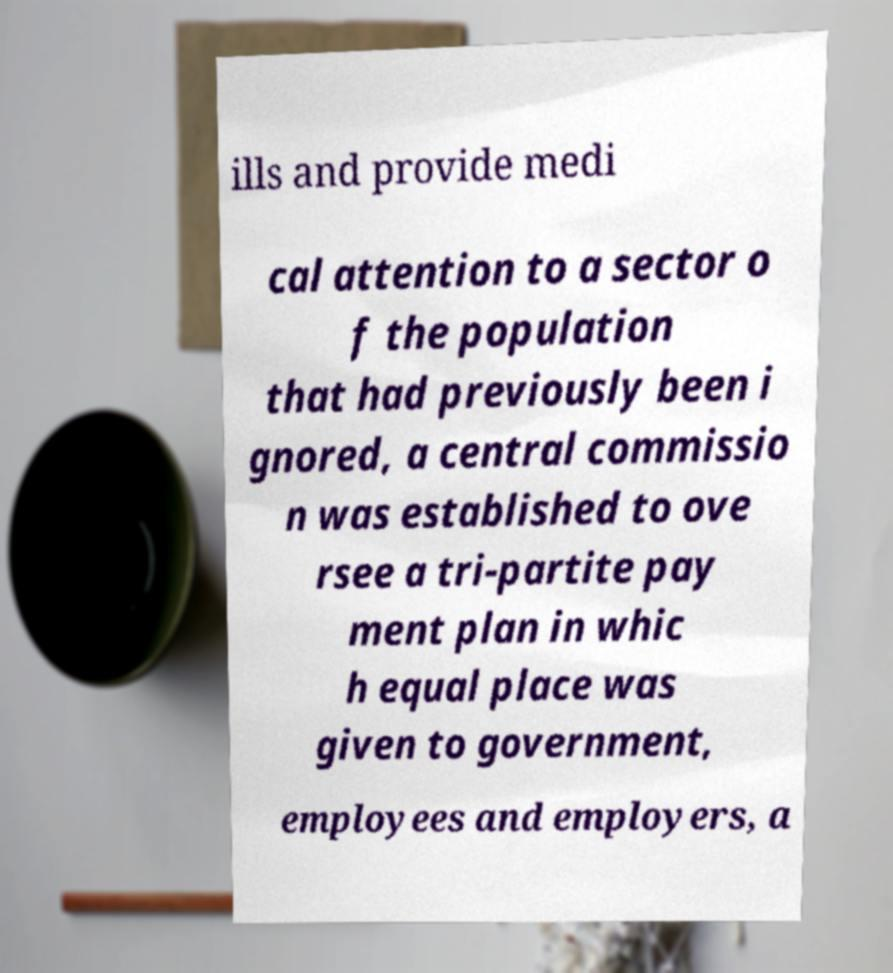Can you accurately transcribe the text from the provided image for me? ills and provide medi cal attention to a sector o f the population that had previously been i gnored, a central commissio n was established to ove rsee a tri-partite pay ment plan in whic h equal place was given to government, employees and employers, a 